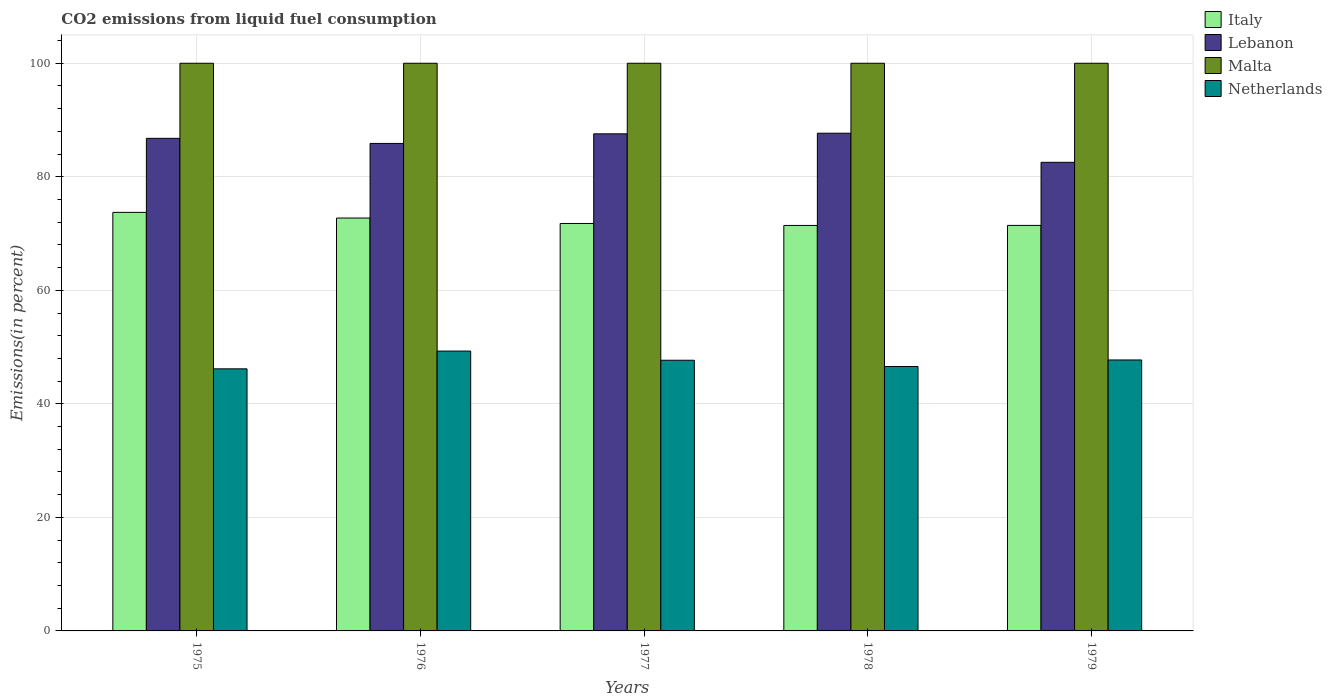How many groups of bars are there?
Make the answer very short. 5. How many bars are there on the 1st tick from the left?
Give a very brief answer. 4. How many bars are there on the 3rd tick from the right?
Provide a short and direct response. 4. What is the label of the 3rd group of bars from the left?
Your response must be concise. 1977. What is the total CO2 emitted in Italy in 1978?
Provide a succinct answer. 71.43. Across all years, what is the maximum total CO2 emitted in Italy?
Your answer should be very brief. 73.73. Across all years, what is the minimum total CO2 emitted in Netherlands?
Your answer should be compact. 46.17. In which year was the total CO2 emitted in Lebanon maximum?
Provide a short and direct response. 1978. In which year was the total CO2 emitted in Italy minimum?
Your answer should be very brief. 1978. What is the total total CO2 emitted in Netherlands in the graph?
Your response must be concise. 237.46. What is the difference between the total CO2 emitted in Netherlands in 1977 and that in 1978?
Your response must be concise. 1.11. What is the difference between the total CO2 emitted in Lebanon in 1977 and the total CO2 emitted in Malta in 1978?
Your response must be concise. -12.43. What is the average total CO2 emitted in Netherlands per year?
Provide a short and direct response. 47.49. In the year 1979, what is the difference between the total CO2 emitted in Netherlands and total CO2 emitted in Malta?
Your response must be concise. -52.27. What is the ratio of the total CO2 emitted in Italy in 1976 to that in 1978?
Your answer should be compact. 1.02. Is the total CO2 emitted in Malta in 1975 less than that in 1979?
Your response must be concise. No. What is the difference between the highest and the second highest total CO2 emitted in Malta?
Give a very brief answer. 0. What is the difference between the highest and the lowest total CO2 emitted in Italy?
Keep it short and to the point. 2.3. In how many years, is the total CO2 emitted in Lebanon greater than the average total CO2 emitted in Lebanon taken over all years?
Provide a succinct answer. 3. Is the sum of the total CO2 emitted in Italy in 1975 and 1978 greater than the maximum total CO2 emitted in Lebanon across all years?
Offer a very short reply. Yes. Is it the case that in every year, the sum of the total CO2 emitted in Italy and total CO2 emitted in Lebanon is greater than the sum of total CO2 emitted in Netherlands and total CO2 emitted in Malta?
Keep it short and to the point. No. Is it the case that in every year, the sum of the total CO2 emitted in Lebanon and total CO2 emitted in Netherlands is greater than the total CO2 emitted in Malta?
Your answer should be very brief. Yes. How many years are there in the graph?
Offer a terse response. 5. Are the values on the major ticks of Y-axis written in scientific E-notation?
Ensure brevity in your answer.  No. Does the graph contain any zero values?
Give a very brief answer. No. Does the graph contain grids?
Offer a very short reply. Yes. Where does the legend appear in the graph?
Keep it short and to the point. Top right. How many legend labels are there?
Your answer should be very brief. 4. What is the title of the graph?
Keep it short and to the point. CO2 emissions from liquid fuel consumption. Does "Afghanistan" appear as one of the legend labels in the graph?
Ensure brevity in your answer.  No. What is the label or title of the X-axis?
Your answer should be very brief. Years. What is the label or title of the Y-axis?
Keep it short and to the point. Emissions(in percent). What is the Emissions(in percent) in Italy in 1975?
Your response must be concise. 73.73. What is the Emissions(in percent) in Lebanon in 1975?
Provide a short and direct response. 86.77. What is the Emissions(in percent) of Netherlands in 1975?
Keep it short and to the point. 46.17. What is the Emissions(in percent) of Italy in 1976?
Ensure brevity in your answer.  72.73. What is the Emissions(in percent) in Lebanon in 1976?
Provide a short and direct response. 85.88. What is the Emissions(in percent) in Malta in 1976?
Keep it short and to the point. 100. What is the Emissions(in percent) in Netherlands in 1976?
Offer a very short reply. 49.3. What is the Emissions(in percent) in Italy in 1977?
Offer a terse response. 71.77. What is the Emissions(in percent) of Lebanon in 1977?
Make the answer very short. 87.57. What is the Emissions(in percent) of Malta in 1977?
Provide a succinct answer. 100. What is the Emissions(in percent) in Netherlands in 1977?
Make the answer very short. 47.68. What is the Emissions(in percent) in Italy in 1978?
Provide a succinct answer. 71.43. What is the Emissions(in percent) of Lebanon in 1978?
Your response must be concise. 87.68. What is the Emissions(in percent) in Malta in 1978?
Make the answer very short. 100. What is the Emissions(in percent) of Netherlands in 1978?
Offer a terse response. 46.58. What is the Emissions(in percent) in Italy in 1979?
Your answer should be compact. 71.44. What is the Emissions(in percent) of Lebanon in 1979?
Provide a short and direct response. 82.55. What is the Emissions(in percent) in Netherlands in 1979?
Make the answer very short. 47.73. Across all years, what is the maximum Emissions(in percent) in Italy?
Provide a short and direct response. 73.73. Across all years, what is the maximum Emissions(in percent) of Lebanon?
Your answer should be compact. 87.68. Across all years, what is the maximum Emissions(in percent) of Netherlands?
Offer a very short reply. 49.3. Across all years, what is the minimum Emissions(in percent) in Italy?
Your answer should be very brief. 71.43. Across all years, what is the minimum Emissions(in percent) in Lebanon?
Your response must be concise. 82.55. Across all years, what is the minimum Emissions(in percent) in Malta?
Make the answer very short. 100. Across all years, what is the minimum Emissions(in percent) of Netherlands?
Your answer should be compact. 46.17. What is the total Emissions(in percent) of Italy in the graph?
Your answer should be very brief. 361.11. What is the total Emissions(in percent) in Lebanon in the graph?
Offer a terse response. 430.44. What is the total Emissions(in percent) of Malta in the graph?
Give a very brief answer. 500. What is the total Emissions(in percent) in Netherlands in the graph?
Keep it short and to the point. 237.46. What is the difference between the Emissions(in percent) of Italy in 1975 and that in 1976?
Your answer should be compact. 1. What is the difference between the Emissions(in percent) of Lebanon in 1975 and that in 1976?
Make the answer very short. 0.9. What is the difference between the Emissions(in percent) of Netherlands in 1975 and that in 1976?
Keep it short and to the point. -3.13. What is the difference between the Emissions(in percent) in Italy in 1975 and that in 1977?
Keep it short and to the point. 1.96. What is the difference between the Emissions(in percent) in Lebanon in 1975 and that in 1977?
Offer a very short reply. -0.79. What is the difference between the Emissions(in percent) of Malta in 1975 and that in 1977?
Give a very brief answer. 0. What is the difference between the Emissions(in percent) of Netherlands in 1975 and that in 1977?
Your response must be concise. -1.51. What is the difference between the Emissions(in percent) of Italy in 1975 and that in 1978?
Your response must be concise. 2.3. What is the difference between the Emissions(in percent) in Lebanon in 1975 and that in 1978?
Provide a short and direct response. -0.9. What is the difference between the Emissions(in percent) in Malta in 1975 and that in 1978?
Ensure brevity in your answer.  0. What is the difference between the Emissions(in percent) in Netherlands in 1975 and that in 1978?
Give a very brief answer. -0.41. What is the difference between the Emissions(in percent) of Italy in 1975 and that in 1979?
Make the answer very short. 2.3. What is the difference between the Emissions(in percent) in Lebanon in 1975 and that in 1979?
Offer a very short reply. 4.22. What is the difference between the Emissions(in percent) of Netherlands in 1975 and that in 1979?
Provide a succinct answer. -1.56. What is the difference between the Emissions(in percent) in Italy in 1976 and that in 1977?
Provide a short and direct response. 0.96. What is the difference between the Emissions(in percent) of Lebanon in 1976 and that in 1977?
Give a very brief answer. -1.69. What is the difference between the Emissions(in percent) of Malta in 1976 and that in 1977?
Your answer should be compact. 0. What is the difference between the Emissions(in percent) of Netherlands in 1976 and that in 1977?
Offer a very short reply. 1.61. What is the difference between the Emissions(in percent) of Italy in 1976 and that in 1978?
Offer a very short reply. 1.3. What is the difference between the Emissions(in percent) in Lebanon in 1976 and that in 1978?
Ensure brevity in your answer.  -1.8. What is the difference between the Emissions(in percent) in Netherlands in 1976 and that in 1978?
Give a very brief answer. 2.72. What is the difference between the Emissions(in percent) of Italy in 1976 and that in 1979?
Provide a succinct answer. 1.3. What is the difference between the Emissions(in percent) of Lebanon in 1976 and that in 1979?
Give a very brief answer. 3.33. What is the difference between the Emissions(in percent) of Netherlands in 1976 and that in 1979?
Provide a succinct answer. 1.57. What is the difference between the Emissions(in percent) of Italy in 1977 and that in 1978?
Provide a succinct answer. 0.34. What is the difference between the Emissions(in percent) of Lebanon in 1977 and that in 1978?
Offer a very short reply. -0.11. What is the difference between the Emissions(in percent) in Malta in 1977 and that in 1978?
Provide a short and direct response. 0. What is the difference between the Emissions(in percent) of Netherlands in 1977 and that in 1978?
Give a very brief answer. 1.11. What is the difference between the Emissions(in percent) in Italy in 1977 and that in 1979?
Offer a terse response. 0.34. What is the difference between the Emissions(in percent) of Lebanon in 1977 and that in 1979?
Keep it short and to the point. 5.02. What is the difference between the Emissions(in percent) of Netherlands in 1977 and that in 1979?
Give a very brief answer. -0.05. What is the difference between the Emissions(in percent) of Italy in 1978 and that in 1979?
Your response must be concise. -0.01. What is the difference between the Emissions(in percent) in Lebanon in 1978 and that in 1979?
Give a very brief answer. 5.13. What is the difference between the Emissions(in percent) of Netherlands in 1978 and that in 1979?
Offer a terse response. -1.16. What is the difference between the Emissions(in percent) in Italy in 1975 and the Emissions(in percent) in Lebanon in 1976?
Keep it short and to the point. -12.14. What is the difference between the Emissions(in percent) in Italy in 1975 and the Emissions(in percent) in Malta in 1976?
Offer a very short reply. -26.27. What is the difference between the Emissions(in percent) in Italy in 1975 and the Emissions(in percent) in Netherlands in 1976?
Make the answer very short. 24.44. What is the difference between the Emissions(in percent) in Lebanon in 1975 and the Emissions(in percent) in Malta in 1976?
Give a very brief answer. -13.23. What is the difference between the Emissions(in percent) of Lebanon in 1975 and the Emissions(in percent) of Netherlands in 1976?
Provide a short and direct response. 37.47. What is the difference between the Emissions(in percent) in Malta in 1975 and the Emissions(in percent) in Netherlands in 1976?
Provide a short and direct response. 50.7. What is the difference between the Emissions(in percent) of Italy in 1975 and the Emissions(in percent) of Lebanon in 1977?
Ensure brevity in your answer.  -13.83. What is the difference between the Emissions(in percent) in Italy in 1975 and the Emissions(in percent) in Malta in 1977?
Provide a short and direct response. -26.27. What is the difference between the Emissions(in percent) in Italy in 1975 and the Emissions(in percent) in Netherlands in 1977?
Make the answer very short. 26.05. What is the difference between the Emissions(in percent) of Lebanon in 1975 and the Emissions(in percent) of Malta in 1977?
Offer a terse response. -13.23. What is the difference between the Emissions(in percent) of Lebanon in 1975 and the Emissions(in percent) of Netherlands in 1977?
Offer a very short reply. 39.09. What is the difference between the Emissions(in percent) of Malta in 1975 and the Emissions(in percent) of Netherlands in 1977?
Your answer should be very brief. 52.32. What is the difference between the Emissions(in percent) in Italy in 1975 and the Emissions(in percent) in Lebanon in 1978?
Offer a terse response. -13.94. What is the difference between the Emissions(in percent) of Italy in 1975 and the Emissions(in percent) of Malta in 1978?
Make the answer very short. -26.27. What is the difference between the Emissions(in percent) of Italy in 1975 and the Emissions(in percent) of Netherlands in 1978?
Your answer should be compact. 27.16. What is the difference between the Emissions(in percent) in Lebanon in 1975 and the Emissions(in percent) in Malta in 1978?
Make the answer very short. -13.23. What is the difference between the Emissions(in percent) of Lebanon in 1975 and the Emissions(in percent) of Netherlands in 1978?
Your answer should be very brief. 40.2. What is the difference between the Emissions(in percent) of Malta in 1975 and the Emissions(in percent) of Netherlands in 1978?
Your answer should be very brief. 53.42. What is the difference between the Emissions(in percent) of Italy in 1975 and the Emissions(in percent) of Lebanon in 1979?
Offer a terse response. -8.82. What is the difference between the Emissions(in percent) of Italy in 1975 and the Emissions(in percent) of Malta in 1979?
Provide a succinct answer. -26.27. What is the difference between the Emissions(in percent) of Italy in 1975 and the Emissions(in percent) of Netherlands in 1979?
Your response must be concise. 26. What is the difference between the Emissions(in percent) in Lebanon in 1975 and the Emissions(in percent) in Malta in 1979?
Make the answer very short. -13.23. What is the difference between the Emissions(in percent) in Lebanon in 1975 and the Emissions(in percent) in Netherlands in 1979?
Offer a very short reply. 39.04. What is the difference between the Emissions(in percent) of Malta in 1975 and the Emissions(in percent) of Netherlands in 1979?
Offer a very short reply. 52.27. What is the difference between the Emissions(in percent) in Italy in 1976 and the Emissions(in percent) in Lebanon in 1977?
Keep it short and to the point. -14.83. What is the difference between the Emissions(in percent) of Italy in 1976 and the Emissions(in percent) of Malta in 1977?
Your answer should be very brief. -27.27. What is the difference between the Emissions(in percent) in Italy in 1976 and the Emissions(in percent) in Netherlands in 1977?
Provide a succinct answer. 25.05. What is the difference between the Emissions(in percent) of Lebanon in 1976 and the Emissions(in percent) of Malta in 1977?
Provide a succinct answer. -14.12. What is the difference between the Emissions(in percent) in Lebanon in 1976 and the Emissions(in percent) in Netherlands in 1977?
Provide a succinct answer. 38.19. What is the difference between the Emissions(in percent) of Malta in 1976 and the Emissions(in percent) of Netherlands in 1977?
Your response must be concise. 52.32. What is the difference between the Emissions(in percent) in Italy in 1976 and the Emissions(in percent) in Lebanon in 1978?
Keep it short and to the point. -14.94. What is the difference between the Emissions(in percent) of Italy in 1976 and the Emissions(in percent) of Malta in 1978?
Offer a very short reply. -27.27. What is the difference between the Emissions(in percent) of Italy in 1976 and the Emissions(in percent) of Netherlands in 1978?
Your response must be concise. 26.16. What is the difference between the Emissions(in percent) in Lebanon in 1976 and the Emissions(in percent) in Malta in 1978?
Make the answer very short. -14.12. What is the difference between the Emissions(in percent) in Lebanon in 1976 and the Emissions(in percent) in Netherlands in 1978?
Provide a succinct answer. 39.3. What is the difference between the Emissions(in percent) in Malta in 1976 and the Emissions(in percent) in Netherlands in 1978?
Give a very brief answer. 53.42. What is the difference between the Emissions(in percent) in Italy in 1976 and the Emissions(in percent) in Lebanon in 1979?
Provide a short and direct response. -9.82. What is the difference between the Emissions(in percent) in Italy in 1976 and the Emissions(in percent) in Malta in 1979?
Your answer should be very brief. -27.27. What is the difference between the Emissions(in percent) of Italy in 1976 and the Emissions(in percent) of Netherlands in 1979?
Ensure brevity in your answer.  25. What is the difference between the Emissions(in percent) in Lebanon in 1976 and the Emissions(in percent) in Malta in 1979?
Keep it short and to the point. -14.12. What is the difference between the Emissions(in percent) in Lebanon in 1976 and the Emissions(in percent) in Netherlands in 1979?
Give a very brief answer. 38.14. What is the difference between the Emissions(in percent) of Malta in 1976 and the Emissions(in percent) of Netherlands in 1979?
Provide a succinct answer. 52.27. What is the difference between the Emissions(in percent) in Italy in 1977 and the Emissions(in percent) in Lebanon in 1978?
Keep it short and to the point. -15.9. What is the difference between the Emissions(in percent) of Italy in 1977 and the Emissions(in percent) of Malta in 1978?
Provide a short and direct response. -28.23. What is the difference between the Emissions(in percent) of Italy in 1977 and the Emissions(in percent) of Netherlands in 1978?
Offer a terse response. 25.2. What is the difference between the Emissions(in percent) in Lebanon in 1977 and the Emissions(in percent) in Malta in 1978?
Provide a succinct answer. -12.43. What is the difference between the Emissions(in percent) of Lebanon in 1977 and the Emissions(in percent) of Netherlands in 1978?
Give a very brief answer. 40.99. What is the difference between the Emissions(in percent) in Malta in 1977 and the Emissions(in percent) in Netherlands in 1978?
Give a very brief answer. 53.42. What is the difference between the Emissions(in percent) of Italy in 1977 and the Emissions(in percent) of Lebanon in 1979?
Your answer should be compact. -10.77. What is the difference between the Emissions(in percent) in Italy in 1977 and the Emissions(in percent) in Malta in 1979?
Give a very brief answer. -28.23. What is the difference between the Emissions(in percent) of Italy in 1977 and the Emissions(in percent) of Netherlands in 1979?
Provide a short and direct response. 24.04. What is the difference between the Emissions(in percent) of Lebanon in 1977 and the Emissions(in percent) of Malta in 1979?
Provide a succinct answer. -12.43. What is the difference between the Emissions(in percent) of Lebanon in 1977 and the Emissions(in percent) of Netherlands in 1979?
Keep it short and to the point. 39.83. What is the difference between the Emissions(in percent) of Malta in 1977 and the Emissions(in percent) of Netherlands in 1979?
Give a very brief answer. 52.27. What is the difference between the Emissions(in percent) in Italy in 1978 and the Emissions(in percent) in Lebanon in 1979?
Provide a succinct answer. -11.12. What is the difference between the Emissions(in percent) of Italy in 1978 and the Emissions(in percent) of Malta in 1979?
Keep it short and to the point. -28.57. What is the difference between the Emissions(in percent) in Italy in 1978 and the Emissions(in percent) in Netherlands in 1979?
Your response must be concise. 23.7. What is the difference between the Emissions(in percent) of Lebanon in 1978 and the Emissions(in percent) of Malta in 1979?
Give a very brief answer. -12.32. What is the difference between the Emissions(in percent) of Lebanon in 1978 and the Emissions(in percent) of Netherlands in 1979?
Ensure brevity in your answer.  39.94. What is the difference between the Emissions(in percent) in Malta in 1978 and the Emissions(in percent) in Netherlands in 1979?
Offer a terse response. 52.27. What is the average Emissions(in percent) of Italy per year?
Your answer should be very brief. 72.22. What is the average Emissions(in percent) of Lebanon per year?
Your answer should be compact. 86.09. What is the average Emissions(in percent) in Malta per year?
Offer a terse response. 100. What is the average Emissions(in percent) of Netherlands per year?
Your answer should be compact. 47.49. In the year 1975, what is the difference between the Emissions(in percent) of Italy and Emissions(in percent) of Lebanon?
Your response must be concise. -13.04. In the year 1975, what is the difference between the Emissions(in percent) of Italy and Emissions(in percent) of Malta?
Offer a terse response. -26.27. In the year 1975, what is the difference between the Emissions(in percent) of Italy and Emissions(in percent) of Netherlands?
Give a very brief answer. 27.56. In the year 1975, what is the difference between the Emissions(in percent) in Lebanon and Emissions(in percent) in Malta?
Give a very brief answer. -13.23. In the year 1975, what is the difference between the Emissions(in percent) of Lebanon and Emissions(in percent) of Netherlands?
Give a very brief answer. 40.6. In the year 1975, what is the difference between the Emissions(in percent) of Malta and Emissions(in percent) of Netherlands?
Give a very brief answer. 53.83. In the year 1976, what is the difference between the Emissions(in percent) of Italy and Emissions(in percent) of Lebanon?
Offer a very short reply. -13.14. In the year 1976, what is the difference between the Emissions(in percent) of Italy and Emissions(in percent) of Malta?
Your answer should be very brief. -27.27. In the year 1976, what is the difference between the Emissions(in percent) of Italy and Emissions(in percent) of Netherlands?
Make the answer very short. 23.43. In the year 1976, what is the difference between the Emissions(in percent) of Lebanon and Emissions(in percent) of Malta?
Make the answer very short. -14.12. In the year 1976, what is the difference between the Emissions(in percent) of Lebanon and Emissions(in percent) of Netherlands?
Provide a succinct answer. 36.58. In the year 1976, what is the difference between the Emissions(in percent) in Malta and Emissions(in percent) in Netherlands?
Offer a terse response. 50.7. In the year 1977, what is the difference between the Emissions(in percent) of Italy and Emissions(in percent) of Lebanon?
Make the answer very short. -15.79. In the year 1977, what is the difference between the Emissions(in percent) in Italy and Emissions(in percent) in Malta?
Make the answer very short. -28.23. In the year 1977, what is the difference between the Emissions(in percent) in Italy and Emissions(in percent) in Netherlands?
Make the answer very short. 24.09. In the year 1977, what is the difference between the Emissions(in percent) in Lebanon and Emissions(in percent) in Malta?
Your answer should be compact. -12.43. In the year 1977, what is the difference between the Emissions(in percent) of Lebanon and Emissions(in percent) of Netherlands?
Give a very brief answer. 39.88. In the year 1977, what is the difference between the Emissions(in percent) in Malta and Emissions(in percent) in Netherlands?
Provide a succinct answer. 52.32. In the year 1978, what is the difference between the Emissions(in percent) of Italy and Emissions(in percent) of Lebanon?
Make the answer very short. -16.25. In the year 1978, what is the difference between the Emissions(in percent) of Italy and Emissions(in percent) of Malta?
Offer a terse response. -28.57. In the year 1978, what is the difference between the Emissions(in percent) of Italy and Emissions(in percent) of Netherlands?
Your answer should be very brief. 24.85. In the year 1978, what is the difference between the Emissions(in percent) of Lebanon and Emissions(in percent) of Malta?
Provide a succinct answer. -12.32. In the year 1978, what is the difference between the Emissions(in percent) of Lebanon and Emissions(in percent) of Netherlands?
Your answer should be compact. 41.1. In the year 1978, what is the difference between the Emissions(in percent) of Malta and Emissions(in percent) of Netherlands?
Your answer should be very brief. 53.42. In the year 1979, what is the difference between the Emissions(in percent) of Italy and Emissions(in percent) of Lebanon?
Your answer should be compact. -11.11. In the year 1979, what is the difference between the Emissions(in percent) in Italy and Emissions(in percent) in Malta?
Make the answer very short. -28.56. In the year 1979, what is the difference between the Emissions(in percent) of Italy and Emissions(in percent) of Netherlands?
Offer a terse response. 23.7. In the year 1979, what is the difference between the Emissions(in percent) in Lebanon and Emissions(in percent) in Malta?
Provide a short and direct response. -17.45. In the year 1979, what is the difference between the Emissions(in percent) in Lebanon and Emissions(in percent) in Netherlands?
Ensure brevity in your answer.  34.82. In the year 1979, what is the difference between the Emissions(in percent) in Malta and Emissions(in percent) in Netherlands?
Your answer should be compact. 52.27. What is the ratio of the Emissions(in percent) in Italy in 1975 to that in 1976?
Provide a short and direct response. 1.01. What is the ratio of the Emissions(in percent) in Lebanon in 1975 to that in 1976?
Offer a terse response. 1.01. What is the ratio of the Emissions(in percent) of Malta in 1975 to that in 1976?
Provide a succinct answer. 1. What is the ratio of the Emissions(in percent) in Netherlands in 1975 to that in 1976?
Provide a short and direct response. 0.94. What is the ratio of the Emissions(in percent) in Italy in 1975 to that in 1977?
Ensure brevity in your answer.  1.03. What is the ratio of the Emissions(in percent) of Lebanon in 1975 to that in 1977?
Offer a very short reply. 0.99. What is the ratio of the Emissions(in percent) in Netherlands in 1975 to that in 1977?
Your response must be concise. 0.97. What is the ratio of the Emissions(in percent) in Italy in 1975 to that in 1978?
Provide a short and direct response. 1.03. What is the ratio of the Emissions(in percent) in Malta in 1975 to that in 1978?
Your answer should be very brief. 1. What is the ratio of the Emissions(in percent) in Netherlands in 1975 to that in 1978?
Offer a terse response. 0.99. What is the ratio of the Emissions(in percent) in Italy in 1975 to that in 1979?
Offer a terse response. 1.03. What is the ratio of the Emissions(in percent) of Lebanon in 1975 to that in 1979?
Provide a succinct answer. 1.05. What is the ratio of the Emissions(in percent) of Netherlands in 1975 to that in 1979?
Give a very brief answer. 0.97. What is the ratio of the Emissions(in percent) of Italy in 1976 to that in 1977?
Ensure brevity in your answer.  1.01. What is the ratio of the Emissions(in percent) in Lebanon in 1976 to that in 1977?
Provide a succinct answer. 0.98. What is the ratio of the Emissions(in percent) in Netherlands in 1976 to that in 1977?
Provide a short and direct response. 1.03. What is the ratio of the Emissions(in percent) in Italy in 1976 to that in 1978?
Make the answer very short. 1.02. What is the ratio of the Emissions(in percent) in Lebanon in 1976 to that in 1978?
Your response must be concise. 0.98. What is the ratio of the Emissions(in percent) of Malta in 1976 to that in 1978?
Your answer should be compact. 1. What is the ratio of the Emissions(in percent) in Netherlands in 1976 to that in 1978?
Keep it short and to the point. 1.06. What is the ratio of the Emissions(in percent) of Italy in 1976 to that in 1979?
Provide a short and direct response. 1.02. What is the ratio of the Emissions(in percent) in Lebanon in 1976 to that in 1979?
Offer a terse response. 1.04. What is the ratio of the Emissions(in percent) of Malta in 1976 to that in 1979?
Your response must be concise. 1. What is the ratio of the Emissions(in percent) of Netherlands in 1976 to that in 1979?
Your response must be concise. 1.03. What is the ratio of the Emissions(in percent) of Netherlands in 1977 to that in 1978?
Provide a succinct answer. 1.02. What is the ratio of the Emissions(in percent) in Italy in 1977 to that in 1979?
Make the answer very short. 1. What is the ratio of the Emissions(in percent) of Lebanon in 1977 to that in 1979?
Provide a short and direct response. 1.06. What is the ratio of the Emissions(in percent) in Malta in 1977 to that in 1979?
Provide a succinct answer. 1. What is the ratio of the Emissions(in percent) of Italy in 1978 to that in 1979?
Your response must be concise. 1. What is the ratio of the Emissions(in percent) in Lebanon in 1978 to that in 1979?
Offer a very short reply. 1.06. What is the ratio of the Emissions(in percent) of Malta in 1978 to that in 1979?
Provide a succinct answer. 1. What is the ratio of the Emissions(in percent) of Netherlands in 1978 to that in 1979?
Make the answer very short. 0.98. What is the difference between the highest and the second highest Emissions(in percent) in Italy?
Ensure brevity in your answer.  1. What is the difference between the highest and the second highest Emissions(in percent) of Lebanon?
Ensure brevity in your answer.  0.11. What is the difference between the highest and the second highest Emissions(in percent) of Netherlands?
Your answer should be compact. 1.57. What is the difference between the highest and the lowest Emissions(in percent) in Italy?
Offer a very short reply. 2.3. What is the difference between the highest and the lowest Emissions(in percent) of Lebanon?
Offer a terse response. 5.13. What is the difference between the highest and the lowest Emissions(in percent) in Malta?
Make the answer very short. 0. What is the difference between the highest and the lowest Emissions(in percent) in Netherlands?
Give a very brief answer. 3.13. 